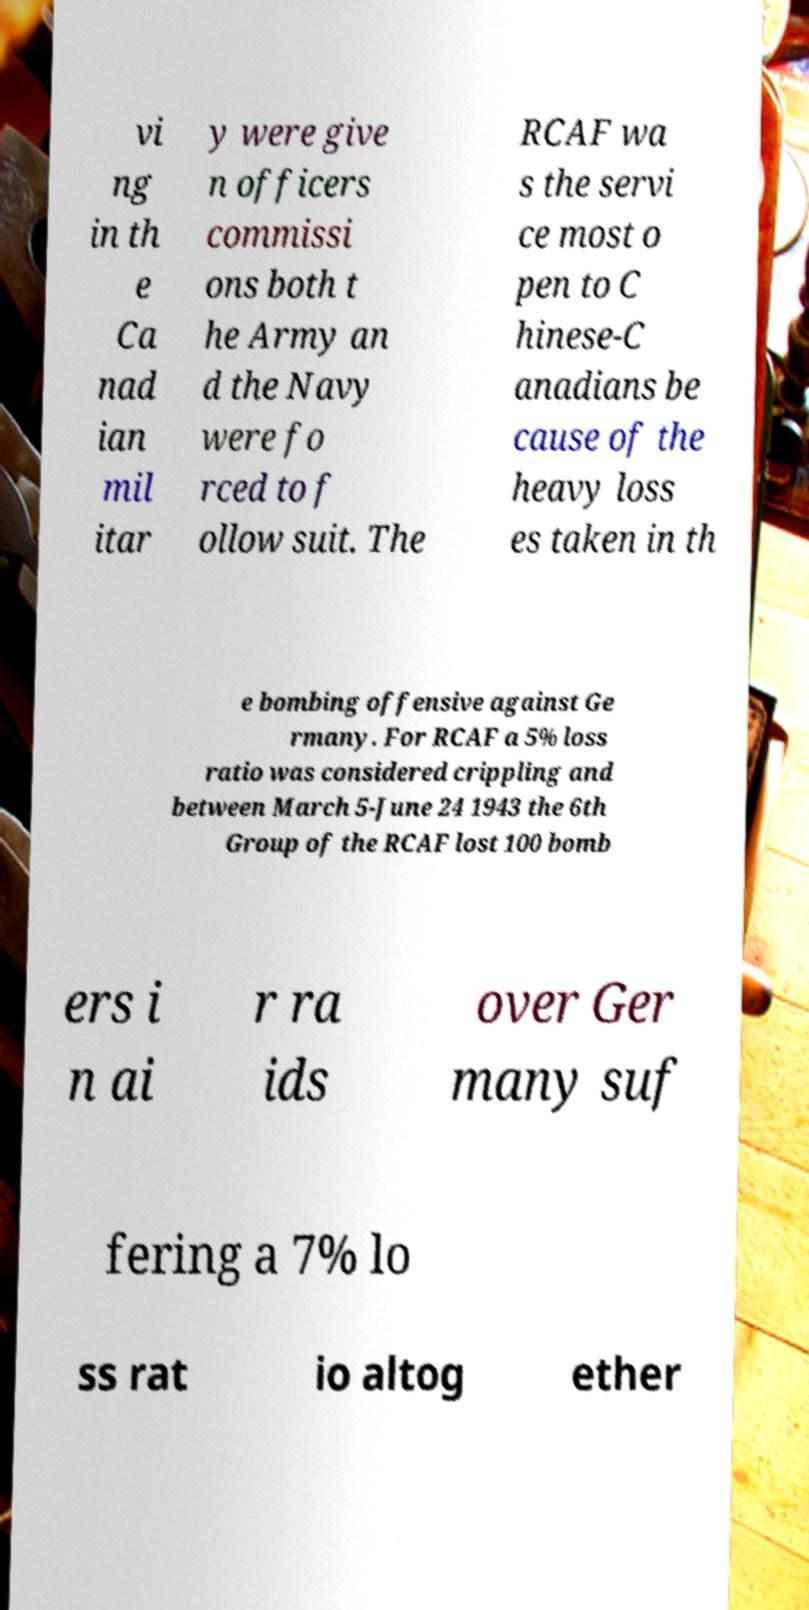What messages or text are displayed in this image? I need them in a readable, typed format. vi ng in th e Ca nad ian mil itar y were give n officers commissi ons both t he Army an d the Navy were fo rced to f ollow suit. The RCAF wa s the servi ce most o pen to C hinese-C anadians be cause of the heavy loss es taken in th e bombing offensive against Ge rmany. For RCAF a 5% loss ratio was considered crippling and between March 5-June 24 1943 the 6th Group of the RCAF lost 100 bomb ers i n ai r ra ids over Ger many suf fering a 7% lo ss rat io altog ether 